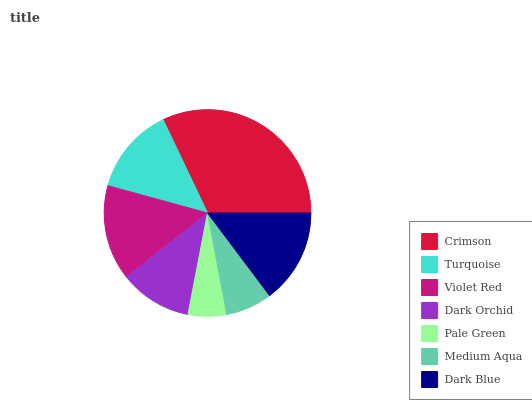Is Pale Green the minimum?
Answer yes or no. Yes. Is Crimson the maximum?
Answer yes or no. Yes. Is Turquoise the minimum?
Answer yes or no. No. Is Turquoise the maximum?
Answer yes or no. No. Is Crimson greater than Turquoise?
Answer yes or no. Yes. Is Turquoise less than Crimson?
Answer yes or no. Yes. Is Turquoise greater than Crimson?
Answer yes or no. No. Is Crimson less than Turquoise?
Answer yes or no. No. Is Turquoise the high median?
Answer yes or no. Yes. Is Turquoise the low median?
Answer yes or no. Yes. Is Dark Orchid the high median?
Answer yes or no. No. Is Dark Orchid the low median?
Answer yes or no. No. 